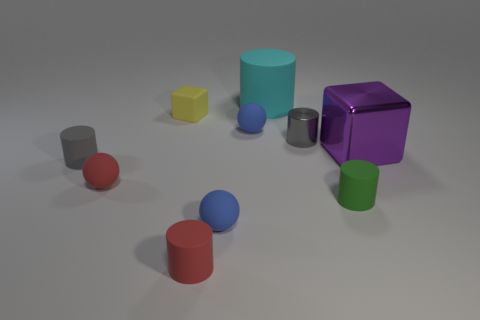Subtract all blue spheres. How many spheres are left? 1 Subtract all green cylinders. How many blue balls are left? 2 Subtract 2 balls. How many balls are left? 1 Subtract 0 brown balls. How many objects are left? 10 Subtract all blocks. How many objects are left? 8 Subtract all blue balls. Subtract all red blocks. How many balls are left? 1 Subtract all big things. Subtract all small yellow matte objects. How many objects are left? 7 Add 2 red matte cylinders. How many red matte cylinders are left? 3 Add 1 brown metallic blocks. How many brown metallic blocks exist? 1 Subtract all purple cubes. How many cubes are left? 1 